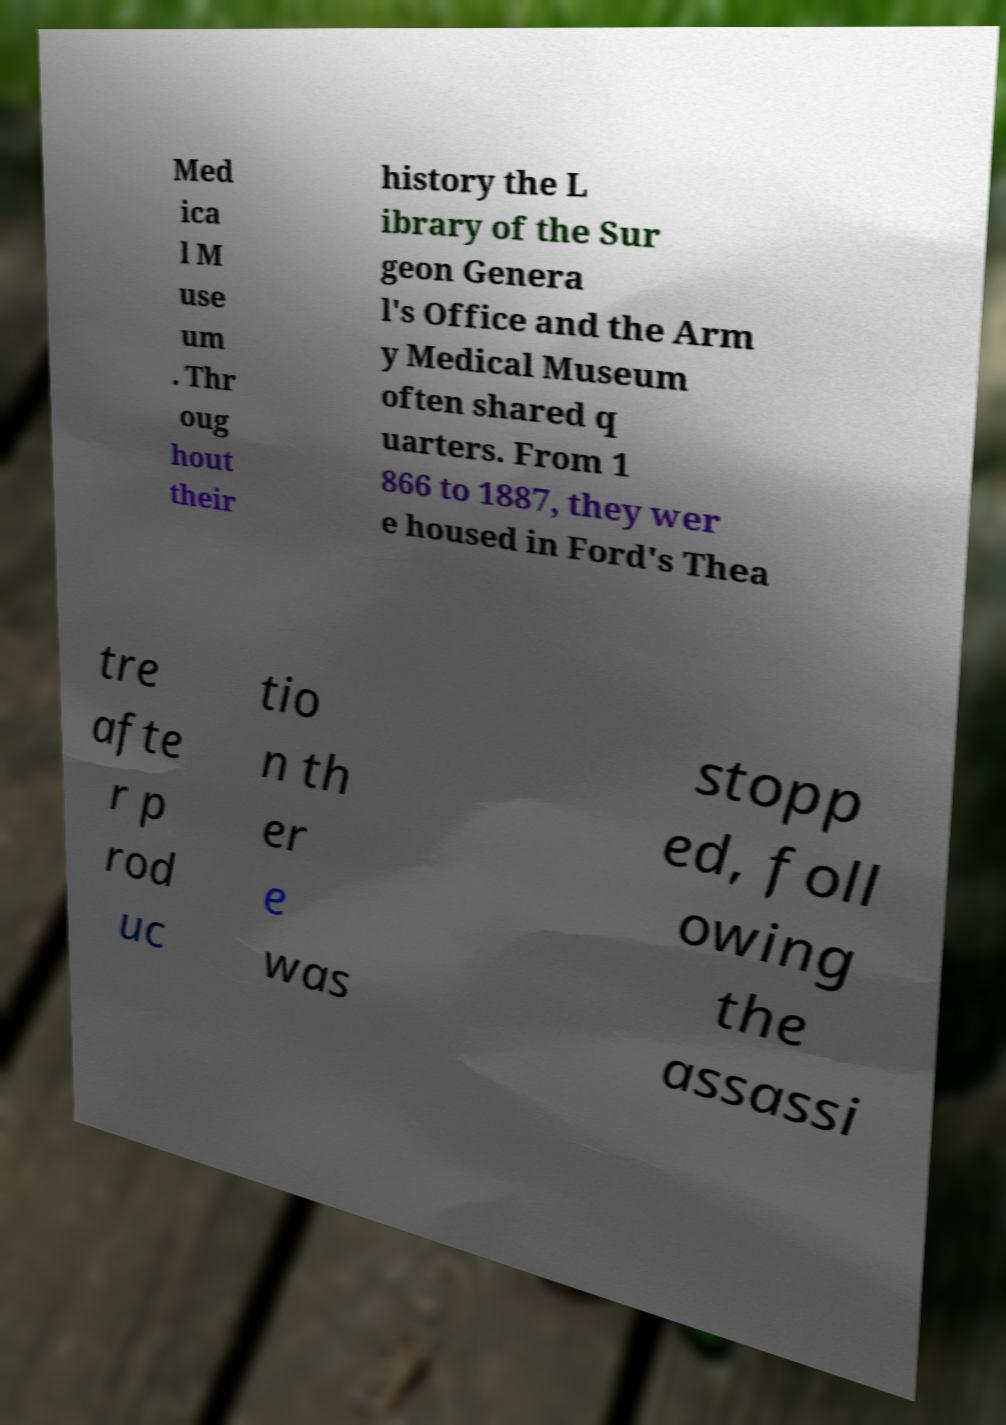Can you accurately transcribe the text from the provided image for me? Med ica l M use um . Thr oug hout their history the L ibrary of the Sur geon Genera l's Office and the Arm y Medical Museum often shared q uarters. From 1 866 to 1887, they wer e housed in Ford's Thea tre afte r p rod uc tio n th er e was stopp ed, foll owing the assassi 